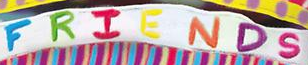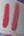Read the text content from these images in order, separated by a semicolon. FRIENDS; " 